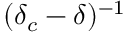<formula> <loc_0><loc_0><loc_500><loc_500>( \delta _ { c } - \delta ) ^ { - 1 }</formula> 